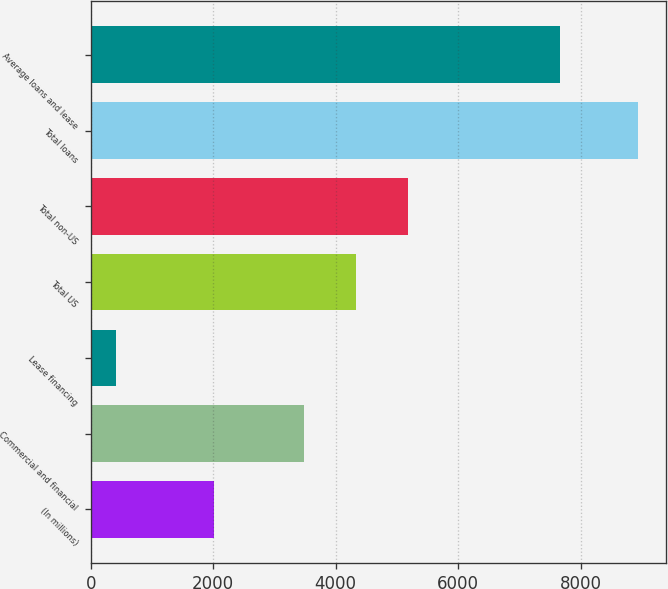Convert chart. <chart><loc_0><loc_0><loc_500><loc_500><bar_chart><fcel>(In millions)<fcel>Commercial and financial<fcel>Lease financing<fcel>Total US<fcel>Total non-US<fcel>Total loans<fcel>Average loans and lease<nl><fcel>2006<fcel>3480<fcel>415<fcel>4333.1<fcel>5186.2<fcel>8946<fcel>7670<nl></chart> 